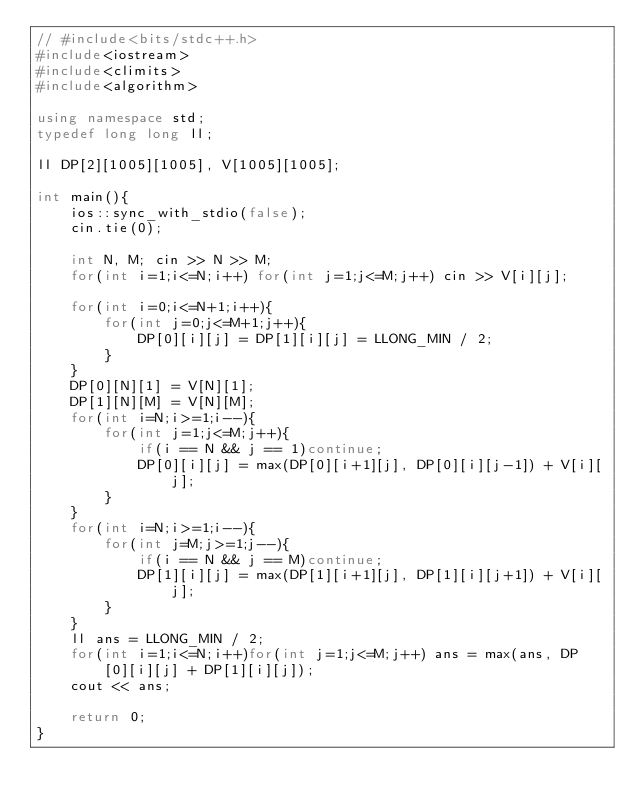Convert code to text. <code><loc_0><loc_0><loc_500><loc_500><_C++_>// #include<bits/stdc++.h>
#include<iostream>
#include<climits>
#include<algorithm>

using namespace std;
typedef long long ll;

ll DP[2][1005][1005], V[1005][1005];

int main(){
    ios::sync_with_stdio(false);
    cin.tie(0);

    int N, M; cin >> N >> M;
    for(int i=1;i<=N;i++) for(int j=1;j<=M;j++) cin >> V[i][j];

    for(int i=0;i<=N+1;i++){
        for(int j=0;j<=M+1;j++){
            DP[0][i][j] = DP[1][i][j] = LLONG_MIN / 2;
        }
    }
    DP[0][N][1] = V[N][1];
    DP[1][N][M] = V[N][M];
    for(int i=N;i>=1;i--){
        for(int j=1;j<=M;j++){
            if(i == N && j == 1)continue;
            DP[0][i][j] = max(DP[0][i+1][j], DP[0][i][j-1]) + V[i][j];
        }
    }
    for(int i=N;i>=1;i--){
        for(int j=M;j>=1;j--){
            if(i == N && j == M)continue;
            DP[1][i][j] = max(DP[1][i+1][j], DP[1][i][j+1]) + V[i][j];
        }
    }
    ll ans = LLONG_MIN / 2;
    for(int i=1;i<=N;i++)for(int j=1;j<=M;j++) ans = max(ans, DP[0][i][j] + DP[1][i][j]);
    cout << ans;

    return 0;
}
</code> 